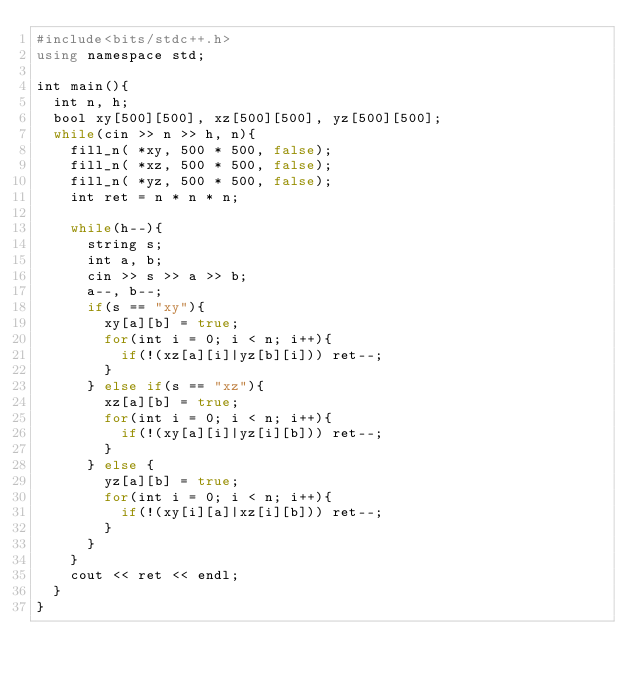Convert code to text. <code><loc_0><loc_0><loc_500><loc_500><_JavaScript_>#include<bits/stdc++.h>
using namespace std;

int main(){
  int n, h;
  bool xy[500][500], xz[500][500], yz[500][500];
  while(cin >> n >> h, n){
    fill_n( *xy, 500 * 500, false);
    fill_n( *xz, 500 * 500, false);
    fill_n( *yz, 500 * 500, false);
    int ret = n * n * n;

    while(h--){
      string s;
      int a, b;
      cin >> s >> a >> b;
      a--, b--;
      if(s == "xy"){
        xy[a][b] = true;
        for(int i = 0; i < n; i++){
          if(!(xz[a][i]|yz[b][i])) ret--;
        }
      } else if(s == "xz"){
        xz[a][b] = true;
        for(int i = 0; i < n; i++){
          if(!(xy[a][i]|yz[i][b])) ret--;
        }
      } else {
        yz[a][b] = true;
        for(int i = 0; i < n; i++){
          if(!(xy[i][a]|xz[i][b])) ret--;
        }
      }
    }
    cout << ret << endl;
  }
}</code> 